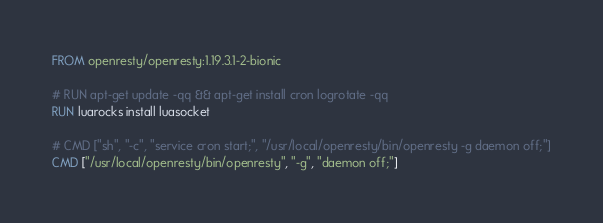Convert code to text. <code><loc_0><loc_0><loc_500><loc_500><_Dockerfile_>FROM openresty/openresty:1.19.3.1-2-bionic

# RUN apt-get update -qq && apt-get install cron logrotate -qq
RUN luarocks install luasocket

# CMD ["sh", "-c", "service cron start;", "/usr/local/openresty/bin/openresty -g daemon off;"]
CMD ["/usr/local/openresty/bin/openresty", "-g", "daemon off;"]
</code> 